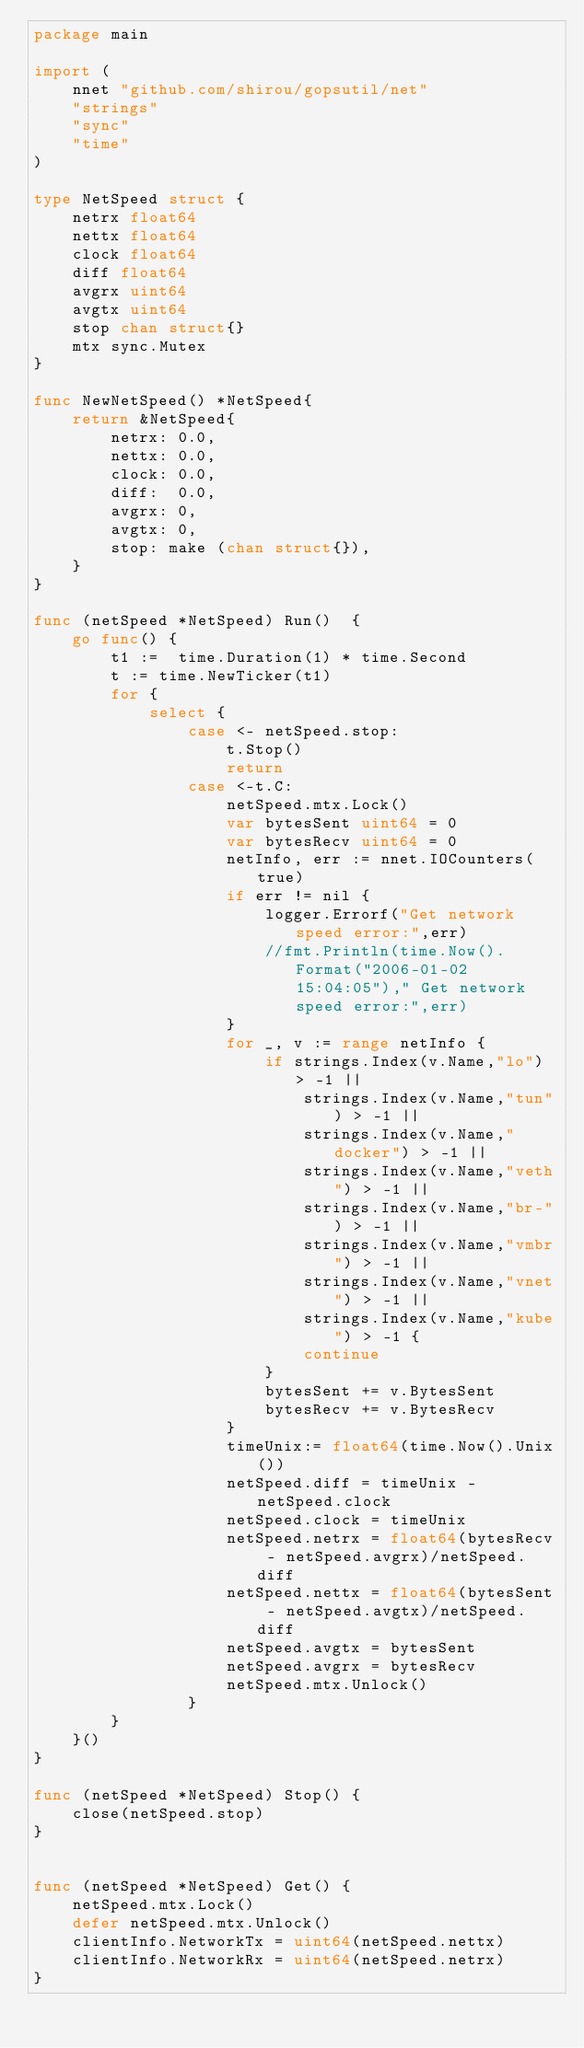Convert code to text. <code><loc_0><loc_0><loc_500><loc_500><_Go_>package main

import (
	nnet "github.com/shirou/gopsutil/net"
	"strings"
	"sync"
	"time"
)

type NetSpeed struct {
	netrx float64
	nettx float64
	clock float64
	diff float64
	avgrx uint64
	avgtx uint64
	stop chan struct{}
	mtx sync.Mutex
}

func NewNetSpeed() *NetSpeed{
	return &NetSpeed{
		netrx: 0.0,
		nettx: 0.0,
		clock: 0.0,
		diff:  0.0,
		avgrx: 0,
		avgtx: 0,
		stop: make (chan struct{}),
	}
}

func (netSpeed *NetSpeed) Run()  {
	go func() {
		t1 :=  time.Duration(1) * time.Second
		t := time.NewTicker(t1)
		for {
			select {
				case <- netSpeed.stop:
					t.Stop()
					return
				case <-t.C:
					netSpeed.mtx.Lock()
					var bytesSent uint64 = 0
					var bytesRecv uint64 = 0
					netInfo, err := nnet.IOCounters(true)
					if err != nil {
						logger.Errorf("Get network speed error:",err)
						//fmt.Println(time.Now().Format("2006-01-02 15:04:05")," Get network speed error:",err)
					}
					for _, v := range netInfo {
						if strings.Index(v.Name,"lo") > -1 ||
							strings.Index(v.Name,"tun") > -1 ||
							strings.Index(v.Name,"docker") > -1 ||
							strings.Index(v.Name,"veth") > -1 ||
							strings.Index(v.Name,"br-") > -1 ||
							strings.Index(v.Name,"vmbr") > -1 ||
							strings.Index(v.Name,"vnet") > -1 ||
							strings.Index(v.Name,"kube") > -1 {
							continue
						}
						bytesSent += v.BytesSent
						bytesRecv += v.BytesRecv
					}
					timeUnix:= float64(time.Now().Unix())
					netSpeed.diff = timeUnix - netSpeed.clock
					netSpeed.clock = timeUnix
					netSpeed.netrx = float64(bytesRecv - netSpeed.avgrx)/netSpeed.diff
					netSpeed.nettx = float64(bytesSent - netSpeed.avgtx)/netSpeed.diff
					netSpeed.avgtx = bytesSent
					netSpeed.avgrx = bytesRecv
					netSpeed.mtx.Unlock()
				}
		}
	}()
}

func (netSpeed *NetSpeed) Stop() {
	close(netSpeed.stop)
}


func (netSpeed *NetSpeed) Get() {
	netSpeed.mtx.Lock()
	defer netSpeed.mtx.Unlock()
	clientInfo.NetworkTx = uint64(netSpeed.nettx)
	clientInfo.NetworkRx = uint64(netSpeed.netrx)
}
</code> 